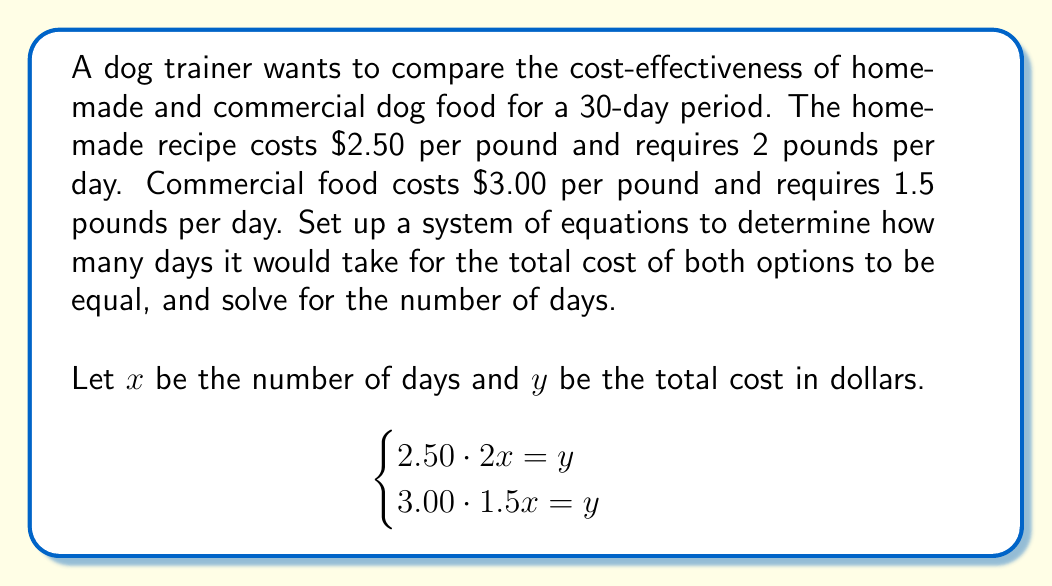Can you solve this math problem? 1) Let's break down the given information:
   - Homemade food: $2.50 per pound, 2 pounds per day
   - Commercial food: $3.00 per pound, 1.5 pounds per day

2) We set up the system of equations:
   $$\begin{cases}
   2.50 \cdot 2x = y \\
   3.00 \cdot 1.5x = y
   \end{cases}$$

3) Simplify the equations:
   $$\begin{cases}
   5x = y \\
   4.5x = y
   \end{cases}$$

4) Since both equations equal $y$, we can set them equal to each other:
   $5x = 4.5x$

5) Subtract $4.5x$ from both sides:
   $0.5x = 0$

6) Divide both sides by 0.5:
   $x = 0$

7) This result means that the costs are equal when $x = 0$, or at the starting point. To interpret this practically, we need to consider the costs over time.

8) For any number of days greater than 0, the homemade food will always be more expensive:
   - Homemade: $5 per day
   - Commercial: $4.50 per day

9) Therefore, commercial food is always more cost-effective in this scenario.
Answer: Commercial food is always more cost-effective; the costs are equal only at day 0. 